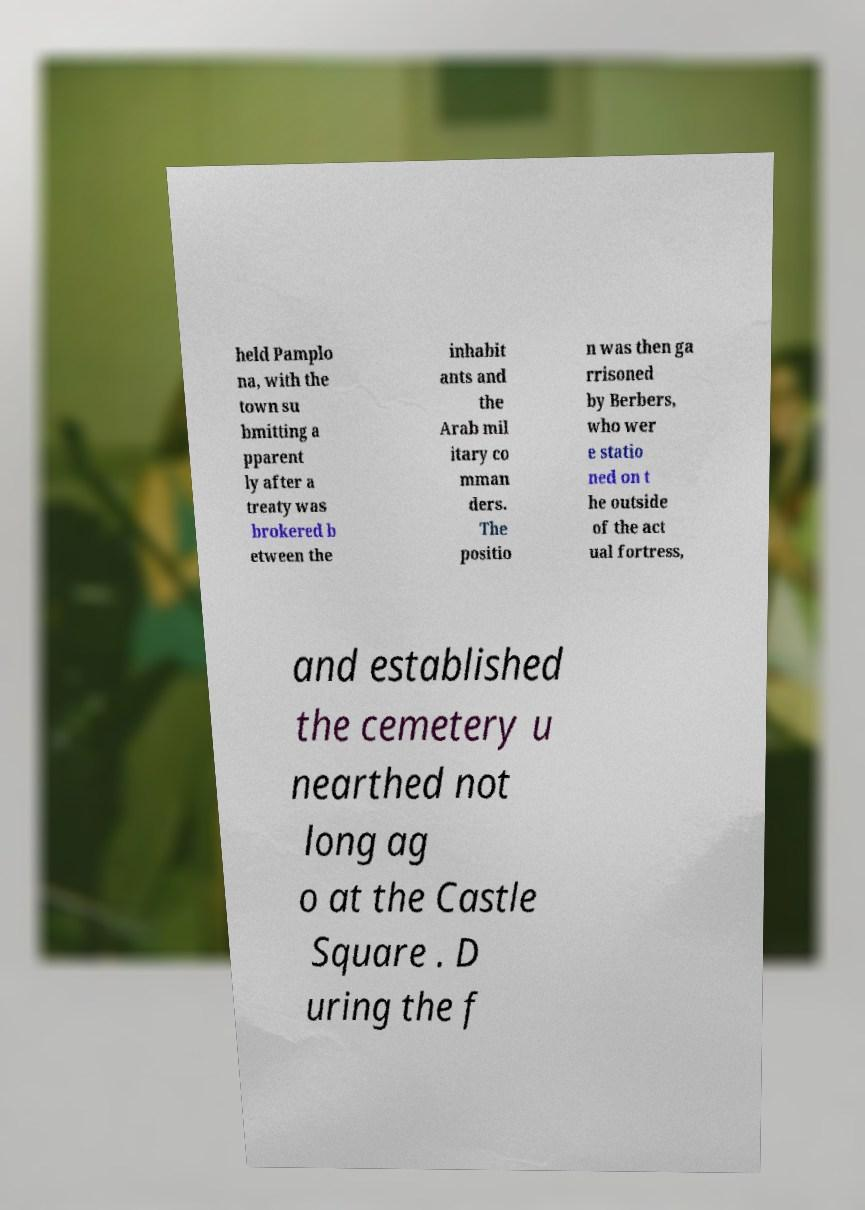Could you assist in decoding the text presented in this image and type it out clearly? held Pamplo na, with the town su bmitting a pparent ly after a treaty was brokered b etween the inhabit ants and the Arab mil itary co mman ders. The positio n was then ga rrisoned by Berbers, who wer e statio ned on t he outside of the act ual fortress, and established the cemetery u nearthed not long ag o at the Castle Square . D uring the f 